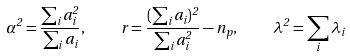<formula> <loc_0><loc_0><loc_500><loc_500>\alpha ^ { 2 } = \frac { \sum _ { i } a _ { i } ^ { 2 } } { \sum _ { i } a _ { i } } , \quad r = \frac { ( \sum _ { i } a _ { i } ) ^ { 2 } } { \sum _ { i } a _ { i } ^ { 2 } } - n _ { p } , \quad \lambda ^ { 2 } = \sum _ { i } \lambda _ { i }</formula> 